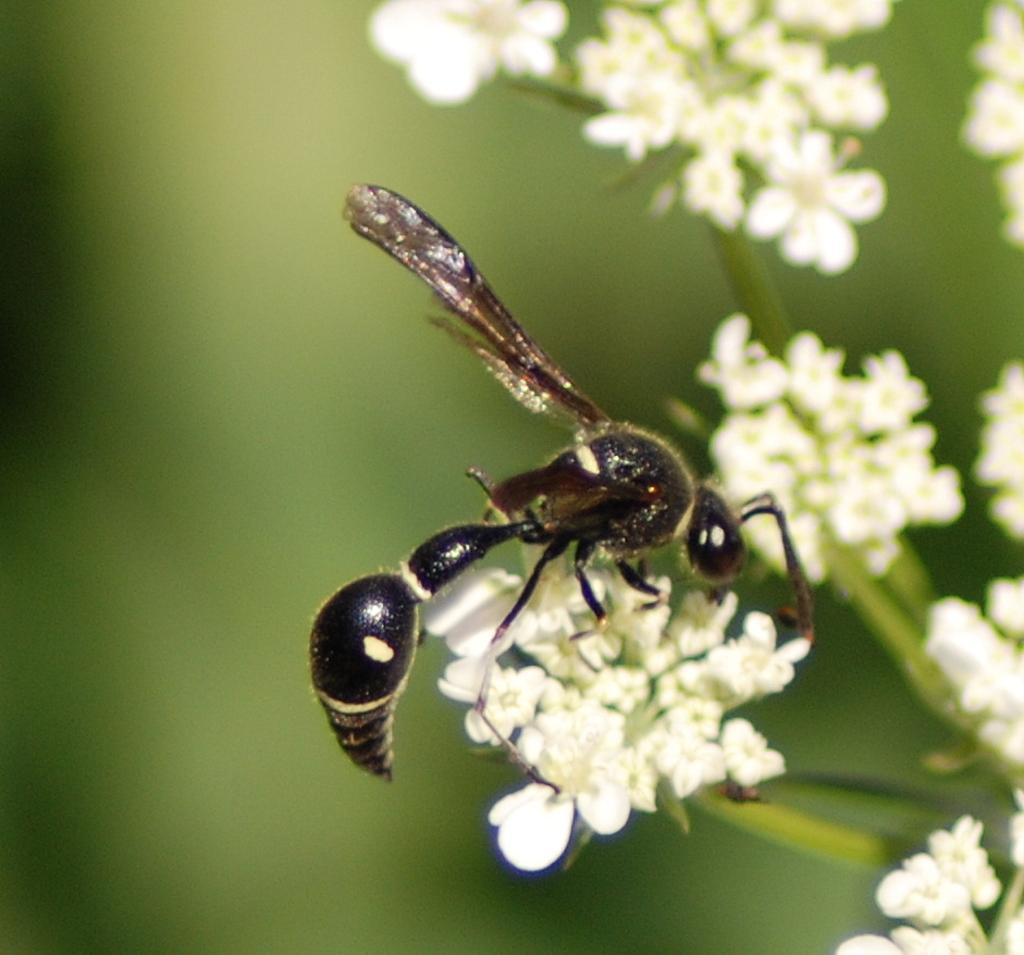Can you describe this image briefly? In the image we can see there is an insect sitting on the flower. 